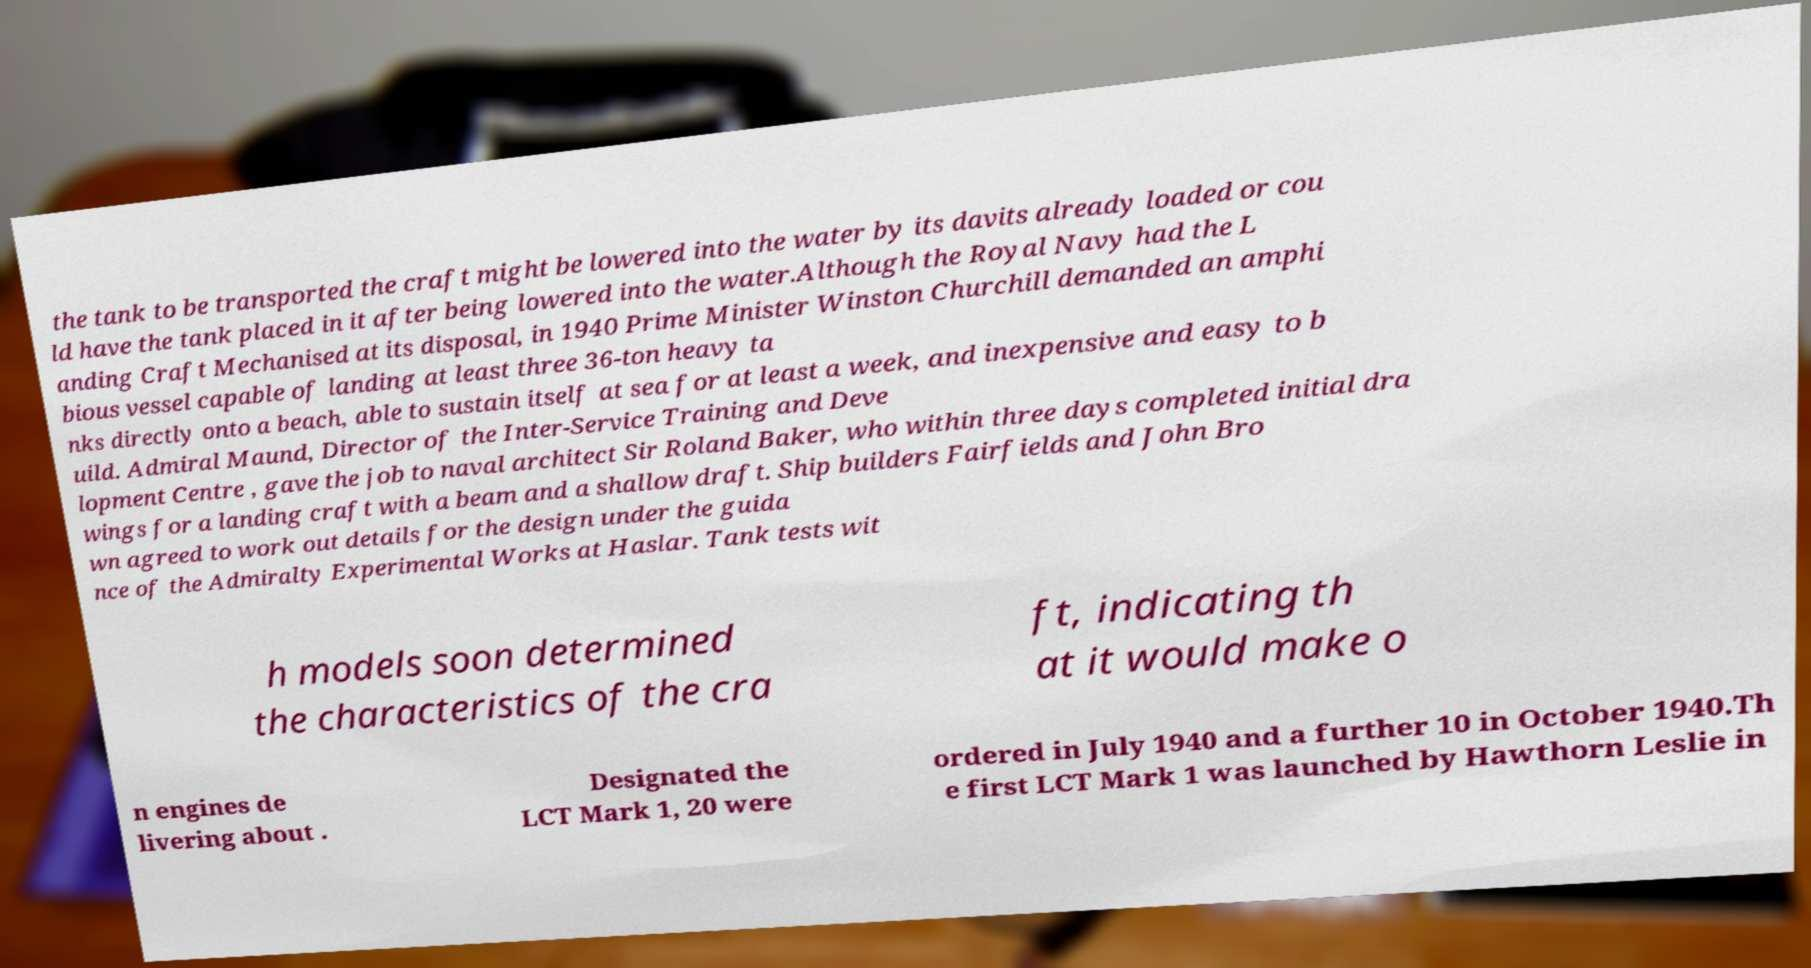Please read and relay the text visible in this image. What does it say? the tank to be transported the craft might be lowered into the water by its davits already loaded or cou ld have the tank placed in it after being lowered into the water.Although the Royal Navy had the L anding Craft Mechanised at its disposal, in 1940 Prime Minister Winston Churchill demanded an amphi bious vessel capable of landing at least three 36-ton heavy ta nks directly onto a beach, able to sustain itself at sea for at least a week, and inexpensive and easy to b uild. Admiral Maund, Director of the Inter-Service Training and Deve lopment Centre , gave the job to naval architect Sir Roland Baker, who within three days completed initial dra wings for a landing craft with a beam and a shallow draft. Ship builders Fairfields and John Bro wn agreed to work out details for the design under the guida nce of the Admiralty Experimental Works at Haslar. Tank tests wit h models soon determined the characteristics of the cra ft, indicating th at it would make o n engines de livering about . Designated the LCT Mark 1, 20 were ordered in July 1940 and a further 10 in October 1940.Th e first LCT Mark 1 was launched by Hawthorn Leslie in 